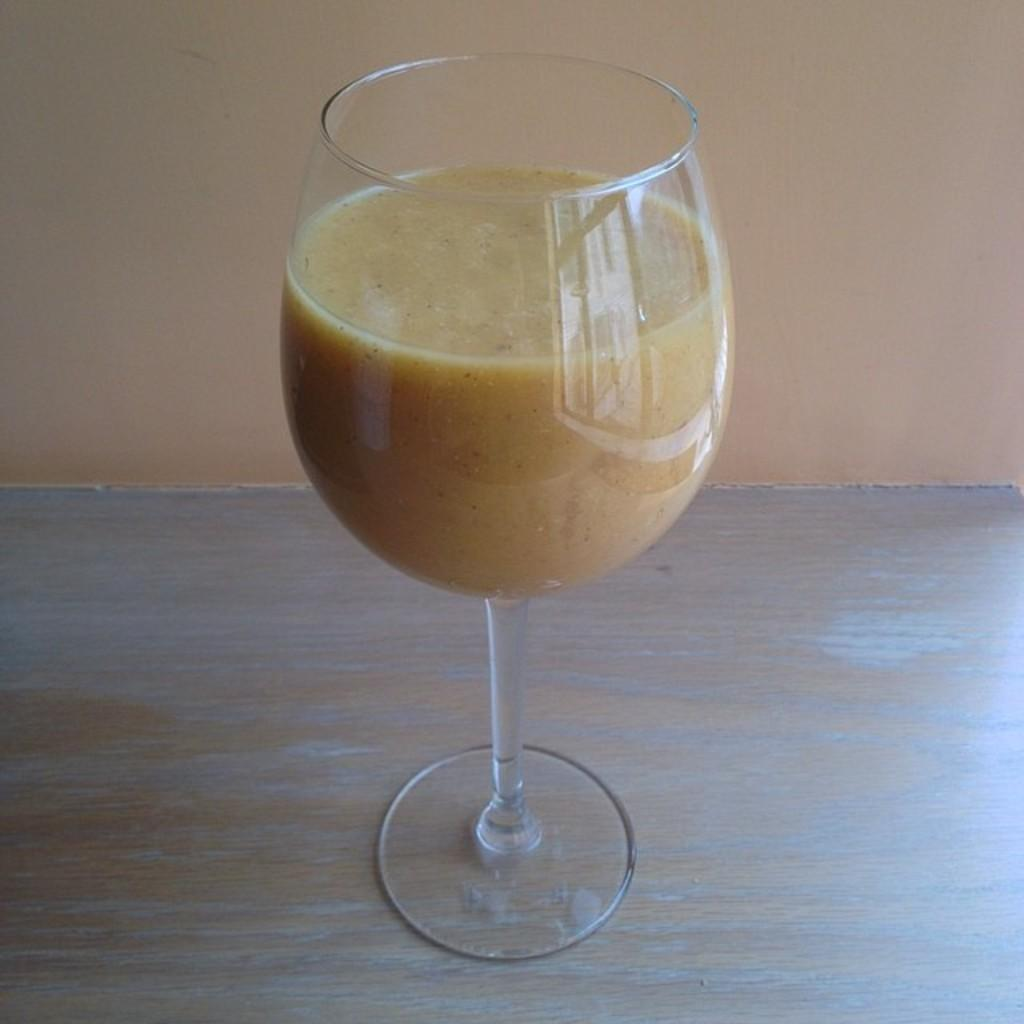What is in the glass that is visible in the image? There is a glass of juice in the image. Where is the glass of juice located? The glass of juice is placed on a surface. How does the pollution affect the cart in the image? There is no cart or pollution present in the image; it only features a glass of juice placed on a surface. 